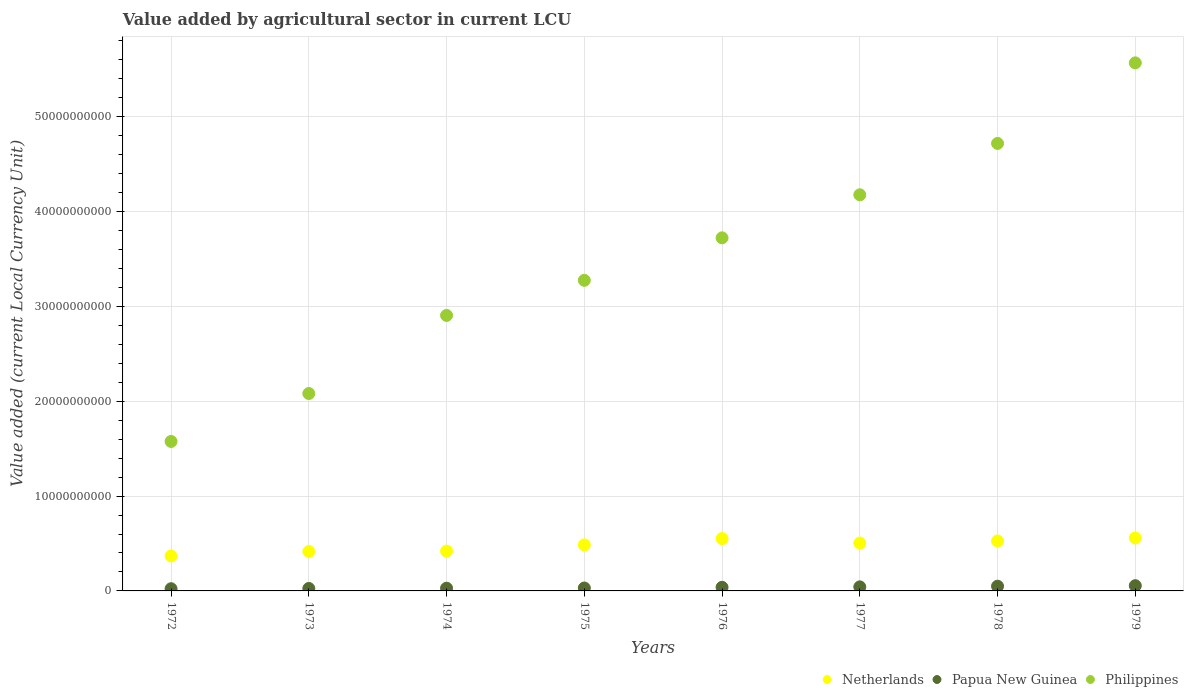What is the value added by agricultural sector in Netherlands in 1978?
Your response must be concise. 5.27e+09. Across all years, what is the maximum value added by agricultural sector in Papua New Guinea?
Make the answer very short. 5.53e+08. Across all years, what is the minimum value added by agricultural sector in Netherlands?
Keep it short and to the point. 3.69e+09. In which year was the value added by agricultural sector in Philippines maximum?
Your answer should be compact. 1979. In which year was the value added by agricultural sector in Netherlands minimum?
Your answer should be very brief. 1972. What is the total value added by agricultural sector in Philippines in the graph?
Your response must be concise. 2.80e+11. What is the difference between the value added by agricultural sector in Philippines in 1974 and that in 1978?
Your response must be concise. -1.81e+1. What is the difference between the value added by agricultural sector in Netherlands in 1972 and the value added by agricultural sector in Papua New Guinea in 1974?
Your answer should be very brief. 3.40e+09. What is the average value added by agricultural sector in Philippines per year?
Your answer should be very brief. 3.50e+1. In the year 1975, what is the difference between the value added by agricultural sector in Papua New Guinea and value added by agricultural sector in Netherlands?
Ensure brevity in your answer.  -4.55e+09. In how many years, is the value added by agricultural sector in Philippines greater than 4000000000 LCU?
Offer a very short reply. 8. What is the ratio of the value added by agricultural sector in Netherlands in 1974 to that in 1978?
Your answer should be very brief. 0.8. Is the value added by agricultural sector in Papua New Guinea in 1975 less than that in 1978?
Give a very brief answer. Yes. Is the difference between the value added by agricultural sector in Papua New Guinea in 1972 and 1974 greater than the difference between the value added by agricultural sector in Netherlands in 1972 and 1974?
Give a very brief answer. Yes. What is the difference between the highest and the second highest value added by agricultural sector in Philippines?
Your answer should be compact. 8.49e+09. What is the difference between the highest and the lowest value added by agricultural sector in Netherlands?
Your answer should be compact. 1.89e+09. In how many years, is the value added by agricultural sector in Philippines greater than the average value added by agricultural sector in Philippines taken over all years?
Offer a very short reply. 4. Is the value added by agricultural sector in Papua New Guinea strictly less than the value added by agricultural sector in Philippines over the years?
Offer a terse response. Yes. How many dotlines are there?
Keep it short and to the point. 3. Does the graph contain any zero values?
Provide a succinct answer. No. Does the graph contain grids?
Provide a succinct answer. Yes. What is the title of the graph?
Offer a terse response. Value added by agricultural sector in current LCU. What is the label or title of the X-axis?
Ensure brevity in your answer.  Years. What is the label or title of the Y-axis?
Your response must be concise. Value added (current Local Currency Unit). What is the Value added (current Local Currency Unit) of Netherlands in 1972?
Your answer should be very brief. 3.69e+09. What is the Value added (current Local Currency Unit) of Papua New Guinea in 1972?
Your answer should be very brief. 2.32e+08. What is the Value added (current Local Currency Unit) of Philippines in 1972?
Provide a short and direct response. 1.58e+1. What is the Value added (current Local Currency Unit) in Netherlands in 1973?
Keep it short and to the point. 4.16e+09. What is the Value added (current Local Currency Unit) in Papua New Guinea in 1973?
Provide a succinct answer. 2.58e+08. What is the Value added (current Local Currency Unit) of Philippines in 1973?
Keep it short and to the point. 2.08e+1. What is the Value added (current Local Currency Unit) in Netherlands in 1974?
Your response must be concise. 4.19e+09. What is the Value added (current Local Currency Unit) in Papua New Guinea in 1974?
Keep it short and to the point. 2.86e+08. What is the Value added (current Local Currency Unit) in Philippines in 1974?
Give a very brief answer. 2.91e+1. What is the Value added (current Local Currency Unit) in Netherlands in 1975?
Your answer should be very brief. 4.86e+09. What is the Value added (current Local Currency Unit) in Papua New Guinea in 1975?
Offer a very short reply. 3.08e+08. What is the Value added (current Local Currency Unit) of Philippines in 1975?
Ensure brevity in your answer.  3.28e+1. What is the Value added (current Local Currency Unit) in Netherlands in 1976?
Your answer should be very brief. 5.52e+09. What is the Value added (current Local Currency Unit) in Papua New Guinea in 1976?
Give a very brief answer. 3.80e+08. What is the Value added (current Local Currency Unit) in Philippines in 1976?
Provide a short and direct response. 3.72e+1. What is the Value added (current Local Currency Unit) of Netherlands in 1977?
Offer a very short reply. 5.05e+09. What is the Value added (current Local Currency Unit) of Papua New Guinea in 1977?
Your response must be concise. 4.28e+08. What is the Value added (current Local Currency Unit) of Philippines in 1977?
Ensure brevity in your answer.  4.18e+1. What is the Value added (current Local Currency Unit) in Netherlands in 1978?
Make the answer very short. 5.27e+09. What is the Value added (current Local Currency Unit) in Papua New Guinea in 1978?
Your answer should be compact. 4.97e+08. What is the Value added (current Local Currency Unit) in Philippines in 1978?
Keep it short and to the point. 4.72e+1. What is the Value added (current Local Currency Unit) in Netherlands in 1979?
Make the answer very short. 5.58e+09. What is the Value added (current Local Currency Unit) of Papua New Guinea in 1979?
Your answer should be very brief. 5.53e+08. What is the Value added (current Local Currency Unit) of Philippines in 1979?
Offer a very short reply. 5.57e+1. Across all years, what is the maximum Value added (current Local Currency Unit) of Netherlands?
Your response must be concise. 5.58e+09. Across all years, what is the maximum Value added (current Local Currency Unit) of Papua New Guinea?
Ensure brevity in your answer.  5.53e+08. Across all years, what is the maximum Value added (current Local Currency Unit) of Philippines?
Provide a succinct answer. 5.57e+1. Across all years, what is the minimum Value added (current Local Currency Unit) in Netherlands?
Your response must be concise. 3.69e+09. Across all years, what is the minimum Value added (current Local Currency Unit) in Papua New Guinea?
Give a very brief answer. 2.32e+08. Across all years, what is the minimum Value added (current Local Currency Unit) of Philippines?
Offer a terse response. 1.58e+1. What is the total Value added (current Local Currency Unit) of Netherlands in the graph?
Keep it short and to the point. 3.83e+1. What is the total Value added (current Local Currency Unit) of Papua New Guinea in the graph?
Offer a very short reply. 2.94e+09. What is the total Value added (current Local Currency Unit) of Philippines in the graph?
Your response must be concise. 2.80e+11. What is the difference between the Value added (current Local Currency Unit) of Netherlands in 1972 and that in 1973?
Offer a terse response. -4.68e+08. What is the difference between the Value added (current Local Currency Unit) of Papua New Guinea in 1972 and that in 1973?
Your answer should be compact. -2.58e+07. What is the difference between the Value added (current Local Currency Unit) of Philippines in 1972 and that in 1973?
Your answer should be very brief. -5.06e+09. What is the difference between the Value added (current Local Currency Unit) of Netherlands in 1972 and that in 1974?
Keep it short and to the point. -5.05e+08. What is the difference between the Value added (current Local Currency Unit) in Papua New Guinea in 1972 and that in 1974?
Provide a succinct answer. -5.40e+07. What is the difference between the Value added (current Local Currency Unit) of Philippines in 1972 and that in 1974?
Provide a succinct answer. -1.33e+1. What is the difference between the Value added (current Local Currency Unit) in Netherlands in 1972 and that in 1975?
Keep it short and to the point. -1.17e+09. What is the difference between the Value added (current Local Currency Unit) of Papua New Guinea in 1972 and that in 1975?
Ensure brevity in your answer.  -7.56e+07. What is the difference between the Value added (current Local Currency Unit) of Philippines in 1972 and that in 1975?
Provide a succinct answer. -1.70e+1. What is the difference between the Value added (current Local Currency Unit) in Netherlands in 1972 and that in 1976?
Your response must be concise. -1.83e+09. What is the difference between the Value added (current Local Currency Unit) in Papua New Guinea in 1972 and that in 1976?
Your answer should be compact. -1.48e+08. What is the difference between the Value added (current Local Currency Unit) of Philippines in 1972 and that in 1976?
Your answer should be compact. -2.15e+1. What is the difference between the Value added (current Local Currency Unit) in Netherlands in 1972 and that in 1977?
Offer a terse response. -1.36e+09. What is the difference between the Value added (current Local Currency Unit) of Papua New Guinea in 1972 and that in 1977?
Keep it short and to the point. -1.96e+08. What is the difference between the Value added (current Local Currency Unit) of Philippines in 1972 and that in 1977?
Provide a succinct answer. -2.60e+1. What is the difference between the Value added (current Local Currency Unit) of Netherlands in 1972 and that in 1978?
Offer a very short reply. -1.58e+09. What is the difference between the Value added (current Local Currency Unit) in Papua New Guinea in 1972 and that in 1978?
Provide a succinct answer. -2.65e+08. What is the difference between the Value added (current Local Currency Unit) in Philippines in 1972 and that in 1978?
Ensure brevity in your answer.  -3.14e+1. What is the difference between the Value added (current Local Currency Unit) of Netherlands in 1972 and that in 1979?
Provide a short and direct response. -1.89e+09. What is the difference between the Value added (current Local Currency Unit) of Papua New Guinea in 1972 and that in 1979?
Your response must be concise. -3.21e+08. What is the difference between the Value added (current Local Currency Unit) of Philippines in 1972 and that in 1979?
Ensure brevity in your answer.  -3.99e+1. What is the difference between the Value added (current Local Currency Unit) in Netherlands in 1973 and that in 1974?
Provide a succinct answer. -3.77e+07. What is the difference between the Value added (current Local Currency Unit) in Papua New Guinea in 1973 and that in 1974?
Keep it short and to the point. -2.82e+07. What is the difference between the Value added (current Local Currency Unit) in Philippines in 1973 and that in 1974?
Provide a succinct answer. -8.23e+09. What is the difference between the Value added (current Local Currency Unit) in Netherlands in 1973 and that in 1975?
Make the answer very short. -6.98e+08. What is the difference between the Value added (current Local Currency Unit) of Papua New Guinea in 1973 and that in 1975?
Your answer should be very brief. -4.98e+07. What is the difference between the Value added (current Local Currency Unit) of Philippines in 1973 and that in 1975?
Give a very brief answer. -1.19e+1. What is the difference between the Value added (current Local Currency Unit) in Netherlands in 1973 and that in 1976?
Provide a succinct answer. -1.36e+09. What is the difference between the Value added (current Local Currency Unit) of Papua New Guinea in 1973 and that in 1976?
Your answer should be compact. -1.22e+08. What is the difference between the Value added (current Local Currency Unit) of Philippines in 1973 and that in 1976?
Your answer should be very brief. -1.64e+1. What is the difference between the Value added (current Local Currency Unit) of Netherlands in 1973 and that in 1977?
Your answer should be compact. -8.92e+08. What is the difference between the Value added (current Local Currency Unit) of Papua New Guinea in 1973 and that in 1977?
Keep it short and to the point. -1.70e+08. What is the difference between the Value added (current Local Currency Unit) of Philippines in 1973 and that in 1977?
Make the answer very short. -2.10e+1. What is the difference between the Value added (current Local Currency Unit) of Netherlands in 1973 and that in 1978?
Provide a short and direct response. -1.12e+09. What is the difference between the Value added (current Local Currency Unit) of Papua New Guinea in 1973 and that in 1978?
Keep it short and to the point. -2.39e+08. What is the difference between the Value added (current Local Currency Unit) in Philippines in 1973 and that in 1978?
Give a very brief answer. -2.64e+1. What is the difference between the Value added (current Local Currency Unit) of Netherlands in 1973 and that in 1979?
Keep it short and to the point. -1.42e+09. What is the difference between the Value added (current Local Currency Unit) of Papua New Guinea in 1973 and that in 1979?
Your response must be concise. -2.95e+08. What is the difference between the Value added (current Local Currency Unit) of Philippines in 1973 and that in 1979?
Make the answer very short. -3.49e+1. What is the difference between the Value added (current Local Currency Unit) of Netherlands in 1974 and that in 1975?
Keep it short and to the point. -6.61e+08. What is the difference between the Value added (current Local Currency Unit) in Papua New Guinea in 1974 and that in 1975?
Offer a terse response. -2.16e+07. What is the difference between the Value added (current Local Currency Unit) in Philippines in 1974 and that in 1975?
Offer a very short reply. -3.70e+09. What is the difference between the Value added (current Local Currency Unit) in Netherlands in 1974 and that in 1976?
Offer a terse response. -1.33e+09. What is the difference between the Value added (current Local Currency Unit) of Papua New Guinea in 1974 and that in 1976?
Give a very brief answer. -9.38e+07. What is the difference between the Value added (current Local Currency Unit) of Philippines in 1974 and that in 1976?
Offer a very short reply. -8.18e+09. What is the difference between the Value added (current Local Currency Unit) of Netherlands in 1974 and that in 1977?
Ensure brevity in your answer.  -8.54e+08. What is the difference between the Value added (current Local Currency Unit) in Papua New Guinea in 1974 and that in 1977?
Ensure brevity in your answer.  -1.42e+08. What is the difference between the Value added (current Local Currency Unit) of Philippines in 1974 and that in 1977?
Ensure brevity in your answer.  -1.27e+1. What is the difference between the Value added (current Local Currency Unit) of Netherlands in 1974 and that in 1978?
Keep it short and to the point. -1.08e+09. What is the difference between the Value added (current Local Currency Unit) of Papua New Guinea in 1974 and that in 1978?
Your answer should be compact. -2.11e+08. What is the difference between the Value added (current Local Currency Unit) in Philippines in 1974 and that in 1978?
Offer a very short reply. -1.81e+1. What is the difference between the Value added (current Local Currency Unit) of Netherlands in 1974 and that in 1979?
Offer a terse response. -1.39e+09. What is the difference between the Value added (current Local Currency Unit) in Papua New Guinea in 1974 and that in 1979?
Offer a very short reply. -2.67e+08. What is the difference between the Value added (current Local Currency Unit) in Philippines in 1974 and that in 1979?
Ensure brevity in your answer.  -2.66e+1. What is the difference between the Value added (current Local Currency Unit) in Netherlands in 1975 and that in 1976?
Provide a short and direct response. -6.65e+08. What is the difference between the Value added (current Local Currency Unit) in Papua New Guinea in 1975 and that in 1976?
Provide a short and direct response. -7.22e+07. What is the difference between the Value added (current Local Currency Unit) in Philippines in 1975 and that in 1976?
Your answer should be compact. -4.48e+09. What is the difference between the Value added (current Local Currency Unit) of Netherlands in 1975 and that in 1977?
Give a very brief answer. -1.94e+08. What is the difference between the Value added (current Local Currency Unit) of Papua New Guinea in 1975 and that in 1977?
Make the answer very short. -1.20e+08. What is the difference between the Value added (current Local Currency Unit) in Philippines in 1975 and that in 1977?
Your answer should be compact. -9.02e+09. What is the difference between the Value added (current Local Currency Unit) of Netherlands in 1975 and that in 1978?
Your answer should be compact. -4.17e+08. What is the difference between the Value added (current Local Currency Unit) in Papua New Guinea in 1975 and that in 1978?
Your answer should be very brief. -1.90e+08. What is the difference between the Value added (current Local Currency Unit) of Philippines in 1975 and that in 1978?
Keep it short and to the point. -1.44e+1. What is the difference between the Value added (current Local Currency Unit) in Netherlands in 1975 and that in 1979?
Make the answer very short. -7.25e+08. What is the difference between the Value added (current Local Currency Unit) of Papua New Guinea in 1975 and that in 1979?
Your answer should be compact. -2.45e+08. What is the difference between the Value added (current Local Currency Unit) of Philippines in 1975 and that in 1979?
Provide a short and direct response. -2.29e+1. What is the difference between the Value added (current Local Currency Unit) of Netherlands in 1976 and that in 1977?
Offer a terse response. 4.71e+08. What is the difference between the Value added (current Local Currency Unit) of Papua New Guinea in 1976 and that in 1977?
Your answer should be very brief. -4.83e+07. What is the difference between the Value added (current Local Currency Unit) in Philippines in 1976 and that in 1977?
Your response must be concise. -4.54e+09. What is the difference between the Value added (current Local Currency Unit) of Netherlands in 1976 and that in 1978?
Keep it short and to the point. 2.48e+08. What is the difference between the Value added (current Local Currency Unit) of Papua New Guinea in 1976 and that in 1978?
Give a very brief answer. -1.17e+08. What is the difference between the Value added (current Local Currency Unit) of Philippines in 1976 and that in 1978?
Provide a short and direct response. -9.96e+09. What is the difference between the Value added (current Local Currency Unit) of Netherlands in 1976 and that in 1979?
Your answer should be compact. -6.03e+07. What is the difference between the Value added (current Local Currency Unit) of Papua New Guinea in 1976 and that in 1979?
Your answer should be very brief. -1.73e+08. What is the difference between the Value added (current Local Currency Unit) in Philippines in 1976 and that in 1979?
Your answer should be compact. -1.85e+1. What is the difference between the Value added (current Local Currency Unit) in Netherlands in 1977 and that in 1978?
Ensure brevity in your answer.  -2.23e+08. What is the difference between the Value added (current Local Currency Unit) of Papua New Guinea in 1977 and that in 1978?
Offer a terse response. -6.92e+07. What is the difference between the Value added (current Local Currency Unit) in Philippines in 1977 and that in 1978?
Provide a succinct answer. -5.42e+09. What is the difference between the Value added (current Local Currency Unit) in Netherlands in 1977 and that in 1979?
Offer a very short reply. -5.31e+08. What is the difference between the Value added (current Local Currency Unit) of Papua New Guinea in 1977 and that in 1979?
Your answer should be compact. -1.24e+08. What is the difference between the Value added (current Local Currency Unit) in Philippines in 1977 and that in 1979?
Provide a succinct answer. -1.39e+1. What is the difference between the Value added (current Local Currency Unit) in Netherlands in 1978 and that in 1979?
Offer a very short reply. -3.08e+08. What is the difference between the Value added (current Local Currency Unit) in Papua New Guinea in 1978 and that in 1979?
Keep it short and to the point. -5.53e+07. What is the difference between the Value added (current Local Currency Unit) of Philippines in 1978 and that in 1979?
Give a very brief answer. -8.49e+09. What is the difference between the Value added (current Local Currency Unit) in Netherlands in 1972 and the Value added (current Local Currency Unit) in Papua New Guinea in 1973?
Your response must be concise. 3.43e+09. What is the difference between the Value added (current Local Currency Unit) of Netherlands in 1972 and the Value added (current Local Currency Unit) of Philippines in 1973?
Your answer should be very brief. -1.71e+1. What is the difference between the Value added (current Local Currency Unit) in Papua New Guinea in 1972 and the Value added (current Local Currency Unit) in Philippines in 1973?
Keep it short and to the point. -2.06e+1. What is the difference between the Value added (current Local Currency Unit) in Netherlands in 1972 and the Value added (current Local Currency Unit) in Papua New Guinea in 1974?
Ensure brevity in your answer.  3.40e+09. What is the difference between the Value added (current Local Currency Unit) in Netherlands in 1972 and the Value added (current Local Currency Unit) in Philippines in 1974?
Your answer should be very brief. -2.54e+1. What is the difference between the Value added (current Local Currency Unit) of Papua New Guinea in 1972 and the Value added (current Local Currency Unit) of Philippines in 1974?
Offer a very short reply. -2.88e+1. What is the difference between the Value added (current Local Currency Unit) in Netherlands in 1972 and the Value added (current Local Currency Unit) in Papua New Guinea in 1975?
Offer a terse response. 3.38e+09. What is the difference between the Value added (current Local Currency Unit) of Netherlands in 1972 and the Value added (current Local Currency Unit) of Philippines in 1975?
Offer a terse response. -2.91e+1. What is the difference between the Value added (current Local Currency Unit) of Papua New Guinea in 1972 and the Value added (current Local Currency Unit) of Philippines in 1975?
Your answer should be compact. -3.25e+1. What is the difference between the Value added (current Local Currency Unit) of Netherlands in 1972 and the Value added (current Local Currency Unit) of Papua New Guinea in 1976?
Give a very brief answer. 3.31e+09. What is the difference between the Value added (current Local Currency Unit) of Netherlands in 1972 and the Value added (current Local Currency Unit) of Philippines in 1976?
Make the answer very short. -3.35e+1. What is the difference between the Value added (current Local Currency Unit) in Papua New Guinea in 1972 and the Value added (current Local Currency Unit) in Philippines in 1976?
Provide a short and direct response. -3.70e+1. What is the difference between the Value added (current Local Currency Unit) of Netherlands in 1972 and the Value added (current Local Currency Unit) of Papua New Guinea in 1977?
Offer a very short reply. 3.26e+09. What is the difference between the Value added (current Local Currency Unit) in Netherlands in 1972 and the Value added (current Local Currency Unit) in Philippines in 1977?
Keep it short and to the point. -3.81e+1. What is the difference between the Value added (current Local Currency Unit) of Papua New Guinea in 1972 and the Value added (current Local Currency Unit) of Philippines in 1977?
Offer a terse response. -4.15e+1. What is the difference between the Value added (current Local Currency Unit) in Netherlands in 1972 and the Value added (current Local Currency Unit) in Papua New Guinea in 1978?
Offer a very short reply. 3.19e+09. What is the difference between the Value added (current Local Currency Unit) in Netherlands in 1972 and the Value added (current Local Currency Unit) in Philippines in 1978?
Provide a short and direct response. -4.35e+1. What is the difference between the Value added (current Local Currency Unit) of Papua New Guinea in 1972 and the Value added (current Local Currency Unit) of Philippines in 1978?
Ensure brevity in your answer.  -4.70e+1. What is the difference between the Value added (current Local Currency Unit) in Netherlands in 1972 and the Value added (current Local Currency Unit) in Papua New Guinea in 1979?
Offer a terse response. 3.14e+09. What is the difference between the Value added (current Local Currency Unit) of Netherlands in 1972 and the Value added (current Local Currency Unit) of Philippines in 1979?
Make the answer very short. -5.20e+1. What is the difference between the Value added (current Local Currency Unit) in Papua New Guinea in 1972 and the Value added (current Local Currency Unit) in Philippines in 1979?
Your response must be concise. -5.55e+1. What is the difference between the Value added (current Local Currency Unit) of Netherlands in 1973 and the Value added (current Local Currency Unit) of Papua New Guinea in 1974?
Your answer should be very brief. 3.87e+09. What is the difference between the Value added (current Local Currency Unit) in Netherlands in 1973 and the Value added (current Local Currency Unit) in Philippines in 1974?
Offer a terse response. -2.49e+1. What is the difference between the Value added (current Local Currency Unit) of Papua New Guinea in 1973 and the Value added (current Local Currency Unit) of Philippines in 1974?
Your answer should be very brief. -2.88e+1. What is the difference between the Value added (current Local Currency Unit) of Netherlands in 1973 and the Value added (current Local Currency Unit) of Papua New Guinea in 1975?
Provide a short and direct response. 3.85e+09. What is the difference between the Value added (current Local Currency Unit) in Netherlands in 1973 and the Value added (current Local Currency Unit) in Philippines in 1975?
Your response must be concise. -2.86e+1. What is the difference between the Value added (current Local Currency Unit) in Papua New Guinea in 1973 and the Value added (current Local Currency Unit) in Philippines in 1975?
Provide a short and direct response. -3.25e+1. What is the difference between the Value added (current Local Currency Unit) in Netherlands in 1973 and the Value added (current Local Currency Unit) in Papua New Guinea in 1976?
Give a very brief answer. 3.78e+09. What is the difference between the Value added (current Local Currency Unit) of Netherlands in 1973 and the Value added (current Local Currency Unit) of Philippines in 1976?
Ensure brevity in your answer.  -3.31e+1. What is the difference between the Value added (current Local Currency Unit) in Papua New Guinea in 1973 and the Value added (current Local Currency Unit) in Philippines in 1976?
Offer a terse response. -3.70e+1. What is the difference between the Value added (current Local Currency Unit) of Netherlands in 1973 and the Value added (current Local Currency Unit) of Papua New Guinea in 1977?
Your answer should be very brief. 3.73e+09. What is the difference between the Value added (current Local Currency Unit) of Netherlands in 1973 and the Value added (current Local Currency Unit) of Philippines in 1977?
Offer a terse response. -3.76e+1. What is the difference between the Value added (current Local Currency Unit) of Papua New Guinea in 1973 and the Value added (current Local Currency Unit) of Philippines in 1977?
Provide a short and direct response. -4.15e+1. What is the difference between the Value added (current Local Currency Unit) of Netherlands in 1973 and the Value added (current Local Currency Unit) of Papua New Guinea in 1978?
Offer a terse response. 3.66e+09. What is the difference between the Value added (current Local Currency Unit) of Netherlands in 1973 and the Value added (current Local Currency Unit) of Philippines in 1978?
Offer a very short reply. -4.30e+1. What is the difference between the Value added (current Local Currency Unit) of Papua New Guinea in 1973 and the Value added (current Local Currency Unit) of Philippines in 1978?
Offer a very short reply. -4.69e+1. What is the difference between the Value added (current Local Currency Unit) of Netherlands in 1973 and the Value added (current Local Currency Unit) of Papua New Guinea in 1979?
Provide a short and direct response. 3.60e+09. What is the difference between the Value added (current Local Currency Unit) of Netherlands in 1973 and the Value added (current Local Currency Unit) of Philippines in 1979?
Offer a very short reply. -5.15e+1. What is the difference between the Value added (current Local Currency Unit) in Papua New Guinea in 1973 and the Value added (current Local Currency Unit) in Philippines in 1979?
Ensure brevity in your answer.  -5.54e+1. What is the difference between the Value added (current Local Currency Unit) in Netherlands in 1974 and the Value added (current Local Currency Unit) in Papua New Guinea in 1975?
Offer a terse response. 3.89e+09. What is the difference between the Value added (current Local Currency Unit) in Netherlands in 1974 and the Value added (current Local Currency Unit) in Philippines in 1975?
Make the answer very short. -2.86e+1. What is the difference between the Value added (current Local Currency Unit) in Papua New Guinea in 1974 and the Value added (current Local Currency Unit) in Philippines in 1975?
Provide a short and direct response. -3.25e+1. What is the difference between the Value added (current Local Currency Unit) in Netherlands in 1974 and the Value added (current Local Currency Unit) in Papua New Guinea in 1976?
Make the answer very short. 3.81e+09. What is the difference between the Value added (current Local Currency Unit) in Netherlands in 1974 and the Value added (current Local Currency Unit) in Philippines in 1976?
Offer a terse response. -3.30e+1. What is the difference between the Value added (current Local Currency Unit) of Papua New Guinea in 1974 and the Value added (current Local Currency Unit) of Philippines in 1976?
Ensure brevity in your answer.  -3.69e+1. What is the difference between the Value added (current Local Currency Unit) in Netherlands in 1974 and the Value added (current Local Currency Unit) in Papua New Guinea in 1977?
Offer a very short reply. 3.77e+09. What is the difference between the Value added (current Local Currency Unit) of Netherlands in 1974 and the Value added (current Local Currency Unit) of Philippines in 1977?
Give a very brief answer. -3.76e+1. What is the difference between the Value added (current Local Currency Unit) in Papua New Guinea in 1974 and the Value added (current Local Currency Unit) in Philippines in 1977?
Make the answer very short. -4.15e+1. What is the difference between the Value added (current Local Currency Unit) in Netherlands in 1974 and the Value added (current Local Currency Unit) in Papua New Guinea in 1978?
Give a very brief answer. 3.70e+09. What is the difference between the Value added (current Local Currency Unit) in Netherlands in 1974 and the Value added (current Local Currency Unit) in Philippines in 1978?
Your response must be concise. -4.30e+1. What is the difference between the Value added (current Local Currency Unit) in Papua New Guinea in 1974 and the Value added (current Local Currency Unit) in Philippines in 1978?
Offer a terse response. -4.69e+1. What is the difference between the Value added (current Local Currency Unit) in Netherlands in 1974 and the Value added (current Local Currency Unit) in Papua New Guinea in 1979?
Your answer should be compact. 3.64e+09. What is the difference between the Value added (current Local Currency Unit) in Netherlands in 1974 and the Value added (current Local Currency Unit) in Philippines in 1979?
Ensure brevity in your answer.  -5.15e+1. What is the difference between the Value added (current Local Currency Unit) in Papua New Guinea in 1974 and the Value added (current Local Currency Unit) in Philippines in 1979?
Offer a very short reply. -5.54e+1. What is the difference between the Value added (current Local Currency Unit) in Netherlands in 1975 and the Value added (current Local Currency Unit) in Papua New Guinea in 1976?
Your answer should be very brief. 4.48e+09. What is the difference between the Value added (current Local Currency Unit) of Netherlands in 1975 and the Value added (current Local Currency Unit) of Philippines in 1976?
Provide a succinct answer. -3.24e+1. What is the difference between the Value added (current Local Currency Unit) in Papua New Guinea in 1975 and the Value added (current Local Currency Unit) in Philippines in 1976?
Your response must be concise. -3.69e+1. What is the difference between the Value added (current Local Currency Unit) in Netherlands in 1975 and the Value added (current Local Currency Unit) in Papua New Guinea in 1977?
Offer a very short reply. 4.43e+09. What is the difference between the Value added (current Local Currency Unit) of Netherlands in 1975 and the Value added (current Local Currency Unit) of Philippines in 1977?
Your answer should be compact. -3.69e+1. What is the difference between the Value added (current Local Currency Unit) in Papua New Guinea in 1975 and the Value added (current Local Currency Unit) in Philippines in 1977?
Keep it short and to the point. -4.15e+1. What is the difference between the Value added (current Local Currency Unit) of Netherlands in 1975 and the Value added (current Local Currency Unit) of Papua New Guinea in 1978?
Your answer should be compact. 4.36e+09. What is the difference between the Value added (current Local Currency Unit) in Netherlands in 1975 and the Value added (current Local Currency Unit) in Philippines in 1978?
Make the answer very short. -4.23e+1. What is the difference between the Value added (current Local Currency Unit) of Papua New Guinea in 1975 and the Value added (current Local Currency Unit) of Philippines in 1978?
Provide a short and direct response. -4.69e+1. What is the difference between the Value added (current Local Currency Unit) in Netherlands in 1975 and the Value added (current Local Currency Unit) in Papua New Guinea in 1979?
Offer a terse response. 4.30e+09. What is the difference between the Value added (current Local Currency Unit) of Netherlands in 1975 and the Value added (current Local Currency Unit) of Philippines in 1979?
Ensure brevity in your answer.  -5.08e+1. What is the difference between the Value added (current Local Currency Unit) of Papua New Guinea in 1975 and the Value added (current Local Currency Unit) of Philippines in 1979?
Make the answer very short. -5.54e+1. What is the difference between the Value added (current Local Currency Unit) of Netherlands in 1976 and the Value added (current Local Currency Unit) of Papua New Guinea in 1977?
Make the answer very short. 5.09e+09. What is the difference between the Value added (current Local Currency Unit) in Netherlands in 1976 and the Value added (current Local Currency Unit) in Philippines in 1977?
Ensure brevity in your answer.  -3.63e+1. What is the difference between the Value added (current Local Currency Unit) of Papua New Guinea in 1976 and the Value added (current Local Currency Unit) of Philippines in 1977?
Provide a short and direct response. -4.14e+1. What is the difference between the Value added (current Local Currency Unit) of Netherlands in 1976 and the Value added (current Local Currency Unit) of Papua New Guinea in 1978?
Give a very brief answer. 5.02e+09. What is the difference between the Value added (current Local Currency Unit) of Netherlands in 1976 and the Value added (current Local Currency Unit) of Philippines in 1978?
Make the answer very short. -4.17e+1. What is the difference between the Value added (current Local Currency Unit) of Papua New Guinea in 1976 and the Value added (current Local Currency Unit) of Philippines in 1978?
Ensure brevity in your answer.  -4.68e+1. What is the difference between the Value added (current Local Currency Unit) in Netherlands in 1976 and the Value added (current Local Currency Unit) in Papua New Guinea in 1979?
Ensure brevity in your answer.  4.97e+09. What is the difference between the Value added (current Local Currency Unit) in Netherlands in 1976 and the Value added (current Local Currency Unit) in Philippines in 1979?
Provide a short and direct response. -5.02e+1. What is the difference between the Value added (current Local Currency Unit) of Papua New Guinea in 1976 and the Value added (current Local Currency Unit) of Philippines in 1979?
Your answer should be very brief. -5.53e+1. What is the difference between the Value added (current Local Currency Unit) in Netherlands in 1977 and the Value added (current Local Currency Unit) in Papua New Guinea in 1978?
Your response must be concise. 4.55e+09. What is the difference between the Value added (current Local Currency Unit) in Netherlands in 1977 and the Value added (current Local Currency Unit) in Philippines in 1978?
Make the answer very short. -4.21e+1. What is the difference between the Value added (current Local Currency Unit) in Papua New Guinea in 1977 and the Value added (current Local Currency Unit) in Philippines in 1978?
Keep it short and to the point. -4.68e+1. What is the difference between the Value added (current Local Currency Unit) in Netherlands in 1977 and the Value added (current Local Currency Unit) in Papua New Guinea in 1979?
Your answer should be compact. 4.50e+09. What is the difference between the Value added (current Local Currency Unit) in Netherlands in 1977 and the Value added (current Local Currency Unit) in Philippines in 1979?
Make the answer very short. -5.06e+1. What is the difference between the Value added (current Local Currency Unit) in Papua New Guinea in 1977 and the Value added (current Local Currency Unit) in Philippines in 1979?
Ensure brevity in your answer.  -5.53e+1. What is the difference between the Value added (current Local Currency Unit) of Netherlands in 1978 and the Value added (current Local Currency Unit) of Papua New Guinea in 1979?
Provide a short and direct response. 4.72e+09. What is the difference between the Value added (current Local Currency Unit) of Netherlands in 1978 and the Value added (current Local Currency Unit) of Philippines in 1979?
Make the answer very short. -5.04e+1. What is the difference between the Value added (current Local Currency Unit) in Papua New Guinea in 1978 and the Value added (current Local Currency Unit) in Philippines in 1979?
Give a very brief answer. -5.52e+1. What is the average Value added (current Local Currency Unit) in Netherlands per year?
Offer a very short reply. 4.79e+09. What is the average Value added (current Local Currency Unit) in Papua New Guinea per year?
Offer a terse response. 3.68e+08. What is the average Value added (current Local Currency Unit) of Philippines per year?
Offer a terse response. 3.50e+1. In the year 1972, what is the difference between the Value added (current Local Currency Unit) in Netherlands and Value added (current Local Currency Unit) in Papua New Guinea?
Offer a very short reply. 3.46e+09. In the year 1972, what is the difference between the Value added (current Local Currency Unit) in Netherlands and Value added (current Local Currency Unit) in Philippines?
Provide a short and direct response. -1.21e+1. In the year 1972, what is the difference between the Value added (current Local Currency Unit) in Papua New Guinea and Value added (current Local Currency Unit) in Philippines?
Ensure brevity in your answer.  -1.55e+1. In the year 1973, what is the difference between the Value added (current Local Currency Unit) of Netherlands and Value added (current Local Currency Unit) of Papua New Guinea?
Provide a succinct answer. 3.90e+09. In the year 1973, what is the difference between the Value added (current Local Currency Unit) in Netherlands and Value added (current Local Currency Unit) in Philippines?
Offer a very short reply. -1.67e+1. In the year 1973, what is the difference between the Value added (current Local Currency Unit) of Papua New Guinea and Value added (current Local Currency Unit) of Philippines?
Offer a terse response. -2.06e+1. In the year 1974, what is the difference between the Value added (current Local Currency Unit) in Netherlands and Value added (current Local Currency Unit) in Papua New Guinea?
Give a very brief answer. 3.91e+09. In the year 1974, what is the difference between the Value added (current Local Currency Unit) in Netherlands and Value added (current Local Currency Unit) in Philippines?
Ensure brevity in your answer.  -2.49e+1. In the year 1974, what is the difference between the Value added (current Local Currency Unit) of Papua New Guinea and Value added (current Local Currency Unit) of Philippines?
Make the answer very short. -2.88e+1. In the year 1975, what is the difference between the Value added (current Local Currency Unit) of Netherlands and Value added (current Local Currency Unit) of Papua New Guinea?
Your answer should be compact. 4.55e+09. In the year 1975, what is the difference between the Value added (current Local Currency Unit) of Netherlands and Value added (current Local Currency Unit) of Philippines?
Your response must be concise. -2.79e+1. In the year 1975, what is the difference between the Value added (current Local Currency Unit) of Papua New Guinea and Value added (current Local Currency Unit) of Philippines?
Your answer should be very brief. -3.24e+1. In the year 1976, what is the difference between the Value added (current Local Currency Unit) of Netherlands and Value added (current Local Currency Unit) of Papua New Guinea?
Provide a short and direct response. 5.14e+09. In the year 1976, what is the difference between the Value added (current Local Currency Unit) of Netherlands and Value added (current Local Currency Unit) of Philippines?
Your answer should be very brief. -3.17e+1. In the year 1976, what is the difference between the Value added (current Local Currency Unit) of Papua New Guinea and Value added (current Local Currency Unit) of Philippines?
Provide a short and direct response. -3.69e+1. In the year 1977, what is the difference between the Value added (current Local Currency Unit) in Netherlands and Value added (current Local Currency Unit) in Papua New Guinea?
Give a very brief answer. 4.62e+09. In the year 1977, what is the difference between the Value added (current Local Currency Unit) in Netherlands and Value added (current Local Currency Unit) in Philippines?
Your answer should be very brief. -3.67e+1. In the year 1977, what is the difference between the Value added (current Local Currency Unit) in Papua New Guinea and Value added (current Local Currency Unit) in Philippines?
Offer a terse response. -4.13e+1. In the year 1978, what is the difference between the Value added (current Local Currency Unit) in Netherlands and Value added (current Local Currency Unit) in Papua New Guinea?
Your answer should be very brief. 4.77e+09. In the year 1978, what is the difference between the Value added (current Local Currency Unit) of Netherlands and Value added (current Local Currency Unit) of Philippines?
Offer a terse response. -4.19e+1. In the year 1978, what is the difference between the Value added (current Local Currency Unit) of Papua New Guinea and Value added (current Local Currency Unit) of Philippines?
Provide a short and direct response. -4.67e+1. In the year 1979, what is the difference between the Value added (current Local Currency Unit) of Netherlands and Value added (current Local Currency Unit) of Papua New Guinea?
Your answer should be compact. 5.03e+09. In the year 1979, what is the difference between the Value added (current Local Currency Unit) in Netherlands and Value added (current Local Currency Unit) in Philippines?
Your response must be concise. -5.01e+1. In the year 1979, what is the difference between the Value added (current Local Currency Unit) in Papua New Guinea and Value added (current Local Currency Unit) in Philippines?
Keep it short and to the point. -5.51e+1. What is the ratio of the Value added (current Local Currency Unit) in Netherlands in 1972 to that in 1973?
Make the answer very short. 0.89. What is the ratio of the Value added (current Local Currency Unit) of Papua New Guinea in 1972 to that in 1973?
Provide a succinct answer. 0.9. What is the ratio of the Value added (current Local Currency Unit) of Philippines in 1972 to that in 1973?
Offer a very short reply. 0.76. What is the ratio of the Value added (current Local Currency Unit) of Netherlands in 1972 to that in 1974?
Provide a short and direct response. 0.88. What is the ratio of the Value added (current Local Currency Unit) of Papua New Guinea in 1972 to that in 1974?
Keep it short and to the point. 0.81. What is the ratio of the Value added (current Local Currency Unit) of Philippines in 1972 to that in 1974?
Your response must be concise. 0.54. What is the ratio of the Value added (current Local Currency Unit) of Netherlands in 1972 to that in 1975?
Keep it short and to the point. 0.76. What is the ratio of the Value added (current Local Currency Unit) of Papua New Guinea in 1972 to that in 1975?
Give a very brief answer. 0.75. What is the ratio of the Value added (current Local Currency Unit) of Philippines in 1972 to that in 1975?
Provide a succinct answer. 0.48. What is the ratio of the Value added (current Local Currency Unit) in Netherlands in 1972 to that in 1976?
Give a very brief answer. 0.67. What is the ratio of the Value added (current Local Currency Unit) in Papua New Guinea in 1972 to that in 1976?
Make the answer very short. 0.61. What is the ratio of the Value added (current Local Currency Unit) of Philippines in 1972 to that in 1976?
Make the answer very short. 0.42. What is the ratio of the Value added (current Local Currency Unit) in Netherlands in 1972 to that in 1977?
Ensure brevity in your answer.  0.73. What is the ratio of the Value added (current Local Currency Unit) in Papua New Guinea in 1972 to that in 1977?
Keep it short and to the point. 0.54. What is the ratio of the Value added (current Local Currency Unit) of Philippines in 1972 to that in 1977?
Offer a terse response. 0.38. What is the ratio of the Value added (current Local Currency Unit) in Netherlands in 1972 to that in 1978?
Give a very brief answer. 0.7. What is the ratio of the Value added (current Local Currency Unit) in Papua New Guinea in 1972 to that in 1978?
Provide a succinct answer. 0.47. What is the ratio of the Value added (current Local Currency Unit) of Philippines in 1972 to that in 1978?
Your response must be concise. 0.33. What is the ratio of the Value added (current Local Currency Unit) of Netherlands in 1972 to that in 1979?
Offer a very short reply. 0.66. What is the ratio of the Value added (current Local Currency Unit) in Papua New Guinea in 1972 to that in 1979?
Your answer should be very brief. 0.42. What is the ratio of the Value added (current Local Currency Unit) in Philippines in 1972 to that in 1979?
Ensure brevity in your answer.  0.28. What is the ratio of the Value added (current Local Currency Unit) in Papua New Guinea in 1973 to that in 1974?
Your answer should be compact. 0.9. What is the ratio of the Value added (current Local Currency Unit) in Philippines in 1973 to that in 1974?
Offer a terse response. 0.72. What is the ratio of the Value added (current Local Currency Unit) of Netherlands in 1973 to that in 1975?
Provide a short and direct response. 0.86. What is the ratio of the Value added (current Local Currency Unit) of Papua New Guinea in 1973 to that in 1975?
Your answer should be very brief. 0.84. What is the ratio of the Value added (current Local Currency Unit) of Philippines in 1973 to that in 1975?
Keep it short and to the point. 0.64. What is the ratio of the Value added (current Local Currency Unit) in Netherlands in 1973 to that in 1976?
Make the answer very short. 0.75. What is the ratio of the Value added (current Local Currency Unit) in Papua New Guinea in 1973 to that in 1976?
Offer a very short reply. 0.68. What is the ratio of the Value added (current Local Currency Unit) of Philippines in 1973 to that in 1976?
Your answer should be very brief. 0.56. What is the ratio of the Value added (current Local Currency Unit) of Netherlands in 1973 to that in 1977?
Provide a short and direct response. 0.82. What is the ratio of the Value added (current Local Currency Unit) in Papua New Guinea in 1973 to that in 1977?
Your answer should be compact. 0.6. What is the ratio of the Value added (current Local Currency Unit) of Philippines in 1973 to that in 1977?
Provide a succinct answer. 0.5. What is the ratio of the Value added (current Local Currency Unit) in Netherlands in 1973 to that in 1978?
Provide a short and direct response. 0.79. What is the ratio of the Value added (current Local Currency Unit) in Papua New Guinea in 1973 to that in 1978?
Offer a very short reply. 0.52. What is the ratio of the Value added (current Local Currency Unit) in Philippines in 1973 to that in 1978?
Offer a terse response. 0.44. What is the ratio of the Value added (current Local Currency Unit) in Netherlands in 1973 to that in 1979?
Keep it short and to the point. 0.74. What is the ratio of the Value added (current Local Currency Unit) of Papua New Guinea in 1973 to that in 1979?
Your response must be concise. 0.47. What is the ratio of the Value added (current Local Currency Unit) in Philippines in 1973 to that in 1979?
Make the answer very short. 0.37. What is the ratio of the Value added (current Local Currency Unit) in Netherlands in 1974 to that in 1975?
Make the answer very short. 0.86. What is the ratio of the Value added (current Local Currency Unit) of Papua New Guinea in 1974 to that in 1975?
Provide a short and direct response. 0.93. What is the ratio of the Value added (current Local Currency Unit) of Philippines in 1974 to that in 1975?
Your answer should be compact. 0.89. What is the ratio of the Value added (current Local Currency Unit) in Netherlands in 1974 to that in 1976?
Make the answer very short. 0.76. What is the ratio of the Value added (current Local Currency Unit) in Papua New Guinea in 1974 to that in 1976?
Provide a succinct answer. 0.75. What is the ratio of the Value added (current Local Currency Unit) of Philippines in 1974 to that in 1976?
Provide a short and direct response. 0.78. What is the ratio of the Value added (current Local Currency Unit) in Netherlands in 1974 to that in 1977?
Provide a short and direct response. 0.83. What is the ratio of the Value added (current Local Currency Unit) in Papua New Guinea in 1974 to that in 1977?
Provide a succinct answer. 0.67. What is the ratio of the Value added (current Local Currency Unit) in Philippines in 1974 to that in 1977?
Provide a short and direct response. 0.7. What is the ratio of the Value added (current Local Currency Unit) in Netherlands in 1974 to that in 1978?
Your answer should be very brief. 0.8. What is the ratio of the Value added (current Local Currency Unit) of Papua New Guinea in 1974 to that in 1978?
Your answer should be very brief. 0.58. What is the ratio of the Value added (current Local Currency Unit) of Philippines in 1974 to that in 1978?
Provide a succinct answer. 0.62. What is the ratio of the Value added (current Local Currency Unit) of Netherlands in 1974 to that in 1979?
Ensure brevity in your answer.  0.75. What is the ratio of the Value added (current Local Currency Unit) of Papua New Guinea in 1974 to that in 1979?
Offer a very short reply. 0.52. What is the ratio of the Value added (current Local Currency Unit) in Philippines in 1974 to that in 1979?
Ensure brevity in your answer.  0.52. What is the ratio of the Value added (current Local Currency Unit) of Netherlands in 1975 to that in 1976?
Your response must be concise. 0.88. What is the ratio of the Value added (current Local Currency Unit) of Papua New Guinea in 1975 to that in 1976?
Offer a very short reply. 0.81. What is the ratio of the Value added (current Local Currency Unit) of Philippines in 1975 to that in 1976?
Keep it short and to the point. 0.88. What is the ratio of the Value added (current Local Currency Unit) of Netherlands in 1975 to that in 1977?
Provide a short and direct response. 0.96. What is the ratio of the Value added (current Local Currency Unit) in Papua New Guinea in 1975 to that in 1977?
Provide a succinct answer. 0.72. What is the ratio of the Value added (current Local Currency Unit) in Philippines in 1975 to that in 1977?
Your response must be concise. 0.78. What is the ratio of the Value added (current Local Currency Unit) of Netherlands in 1975 to that in 1978?
Offer a terse response. 0.92. What is the ratio of the Value added (current Local Currency Unit) of Papua New Guinea in 1975 to that in 1978?
Offer a very short reply. 0.62. What is the ratio of the Value added (current Local Currency Unit) in Philippines in 1975 to that in 1978?
Ensure brevity in your answer.  0.69. What is the ratio of the Value added (current Local Currency Unit) in Netherlands in 1975 to that in 1979?
Give a very brief answer. 0.87. What is the ratio of the Value added (current Local Currency Unit) in Papua New Guinea in 1975 to that in 1979?
Your answer should be compact. 0.56. What is the ratio of the Value added (current Local Currency Unit) in Philippines in 1975 to that in 1979?
Offer a very short reply. 0.59. What is the ratio of the Value added (current Local Currency Unit) in Netherlands in 1976 to that in 1977?
Your answer should be very brief. 1.09. What is the ratio of the Value added (current Local Currency Unit) in Papua New Guinea in 1976 to that in 1977?
Offer a very short reply. 0.89. What is the ratio of the Value added (current Local Currency Unit) of Philippines in 1976 to that in 1977?
Your response must be concise. 0.89. What is the ratio of the Value added (current Local Currency Unit) in Netherlands in 1976 to that in 1978?
Give a very brief answer. 1.05. What is the ratio of the Value added (current Local Currency Unit) in Papua New Guinea in 1976 to that in 1978?
Give a very brief answer. 0.76. What is the ratio of the Value added (current Local Currency Unit) in Philippines in 1976 to that in 1978?
Provide a short and direct response. 0.79. What is the ratio of the Value added (current Local Currency Unit) in Papua New Guinea in 1976 to that in 1979?
Give a very brief answer. 0.69. What is the ratio of the Value added (current Local Currency Unit) of Philippines in 1976 to that in 1979?
Offer a very short reply. 0.67. What is the ratio of the Value added (current Local Currency Unit) of Netherlands in 1977 to that in 1978?
Provide a succinct answer. 0.96. What is the ratio of the Value added (current Local Currency Unit) of Papua New Guinea in 1977 to that in 1978?
Your answer should be compact. 0.86. What is the ratio of the Value added (current Local Currency Unit) of Philippines in 1977 to that in 1978?
Provide a short and direct response. 0.89. What is the ratio of the Value added (current Local Currency Unit) of Netherlands in 1977 to that in 1979?
Make the answer very short. 0.9. What is the ratio of the Value added (current Local Currency Unit) in Papua New Guinea in 1977 to that in 1979?
Provide a short and direct response. 0.77. What is the ratio of the Value added (current Local Currency Unit) of Philippines in 1977 to that in 1979?
Offer a very short reply. 0.75. What is the ratio of the Value added (current Local Currency Unit) of Netherlands in 1978 to that in 1979?
Provide a short and direct response. 0.94. What is the ratio of the Value added (current Local Currency Unit) of Papua New Guinea in 1978 to that in 1979?
Offer a very short reply. 0.9. What is the ratio of the Value added (current Local Currency Unit) in Philippines in 1978 to that in 1979?
Keep it short and to the point. 0.85. What is the difference between the highest and the second highest Value added (current Local Currency Unit) of Netherlands?
Give a very brief answer. 6.03e+07. What is the difference between the highest and the second highest Value added (current Local Currency Unit) in Papua New Guinea?
Provide a short and direct response. 5.53e+07. What is the difference between the highest and the second highest Value added (current Local Currency Unit) of Philippines?
Ensure brevity in your answer.  8.49e+09. What is the difference between the highest and the lowest Value added (current Local Currency Unit) in Netherlands?
Provide a short and direct response. 1.89e+09. What is the difference between the highest and the lowest Value added (current Local Currency Unit) of Papua New Guinea?
Offer a very short reply. 3.21e+08. What is the difference between the highest and the lowest Value added (current Local Currency Unit) of Philippines?
Ensure brevity in your answer.  3.99e+1. 